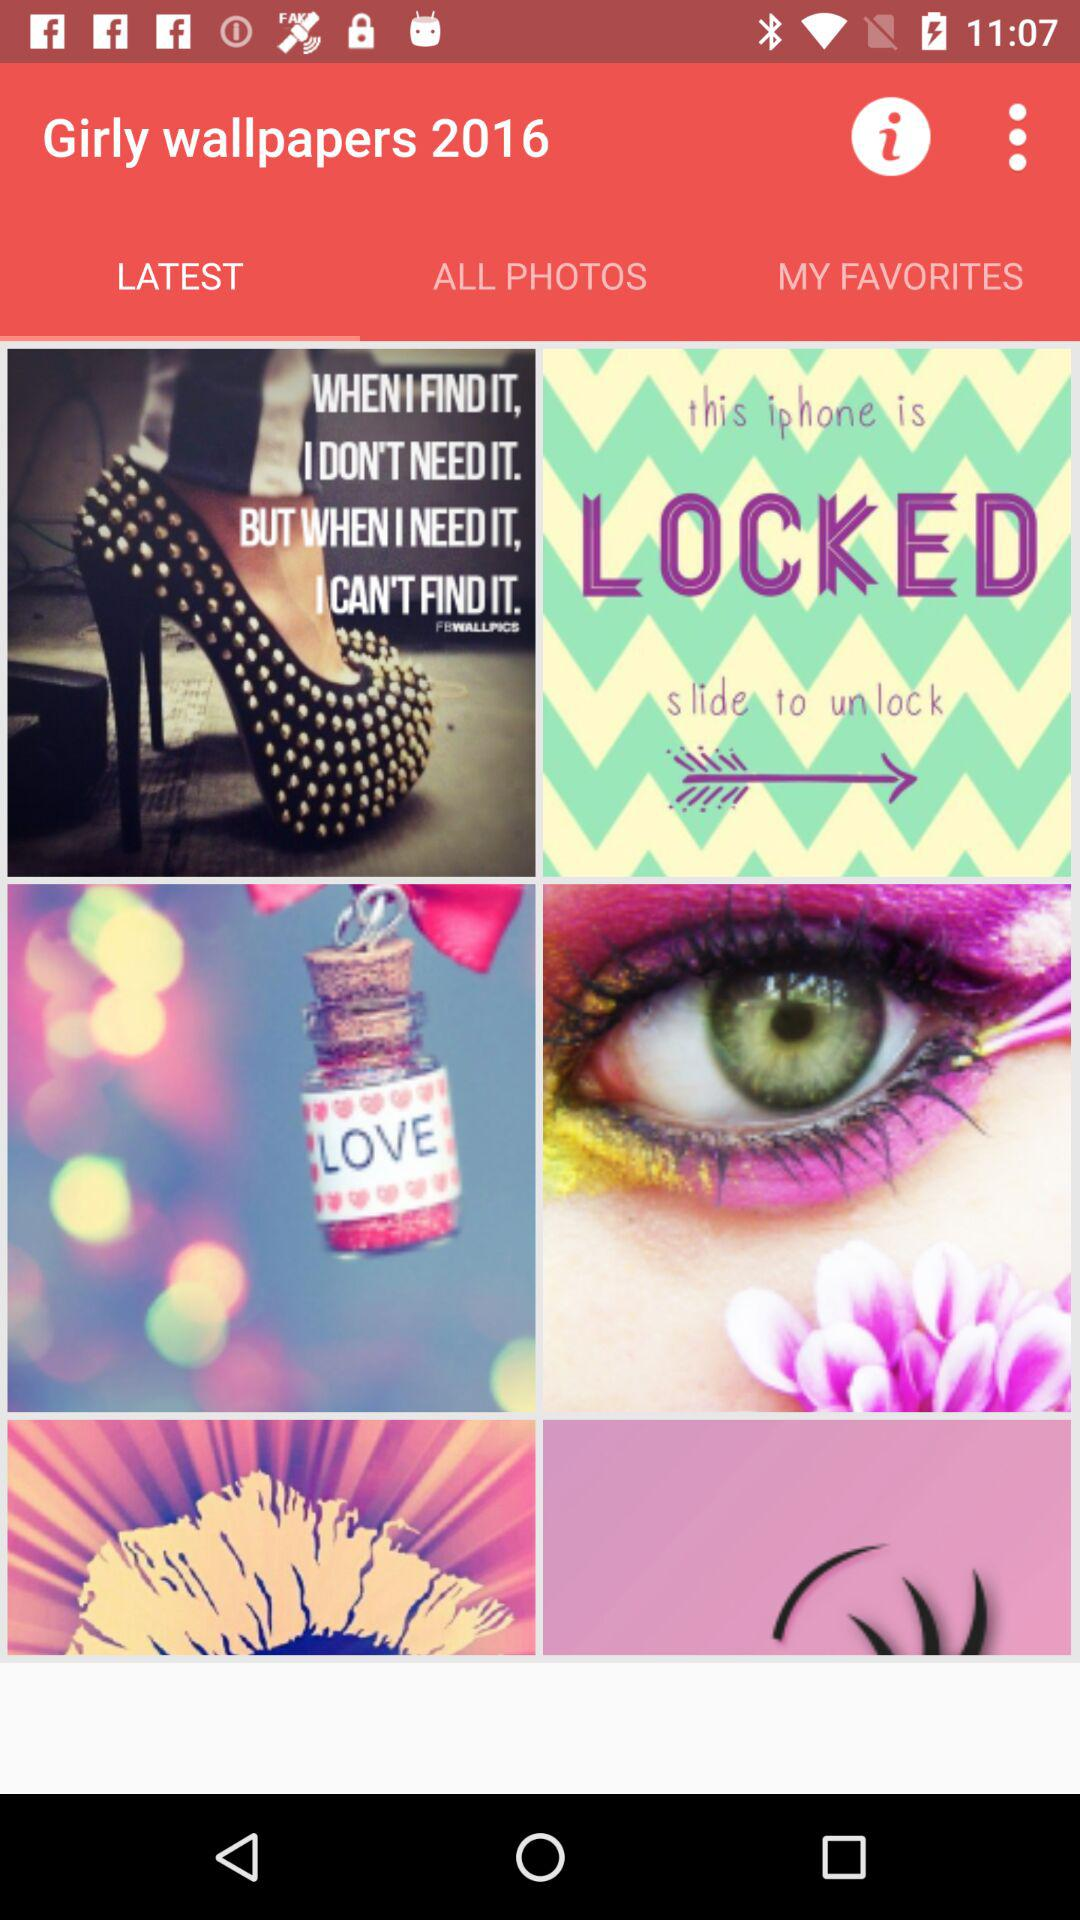What is the mentioned year? The mentioned year is 2016. 